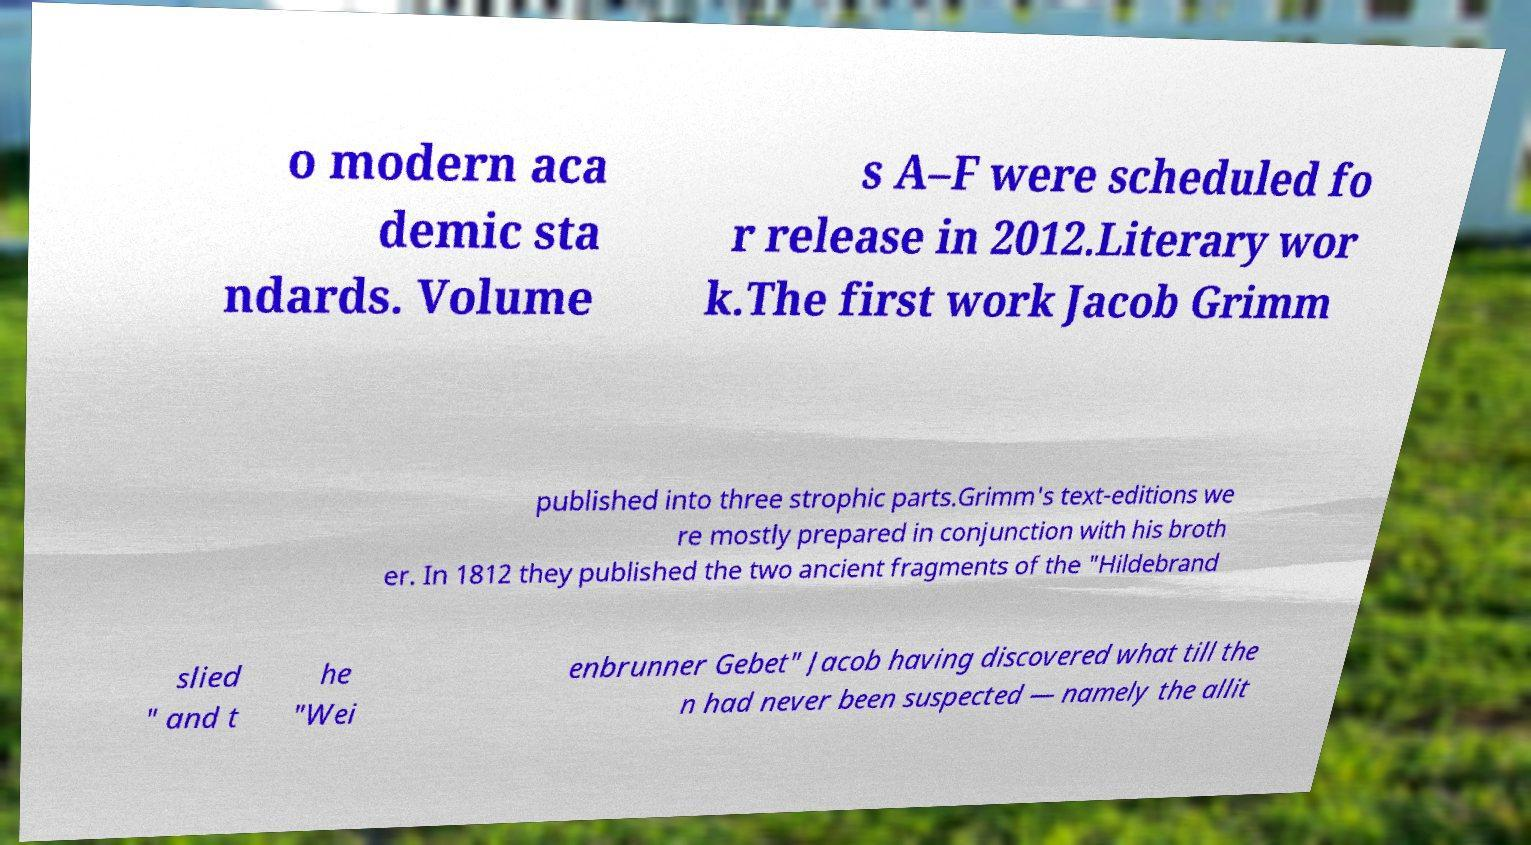Can you read and provide the text displayed in the image?This photo seems to have some interesting text. Can you extract and type it out for me? o modern aca demic sta ndards. Volume s A–F were scheduled fo r release in 2012.Literary wor k.The first work Jacob Grimm published into three strophic parts.Grimm's text-editions we re mostly prepared in conjunction with his broth er. In 1812 they published the two ancient fragments of the "Hildebrand slied " and t he "Wei enbrunner Gebet" Jacob having discovered what till the n had never been suspected — namely the allit 